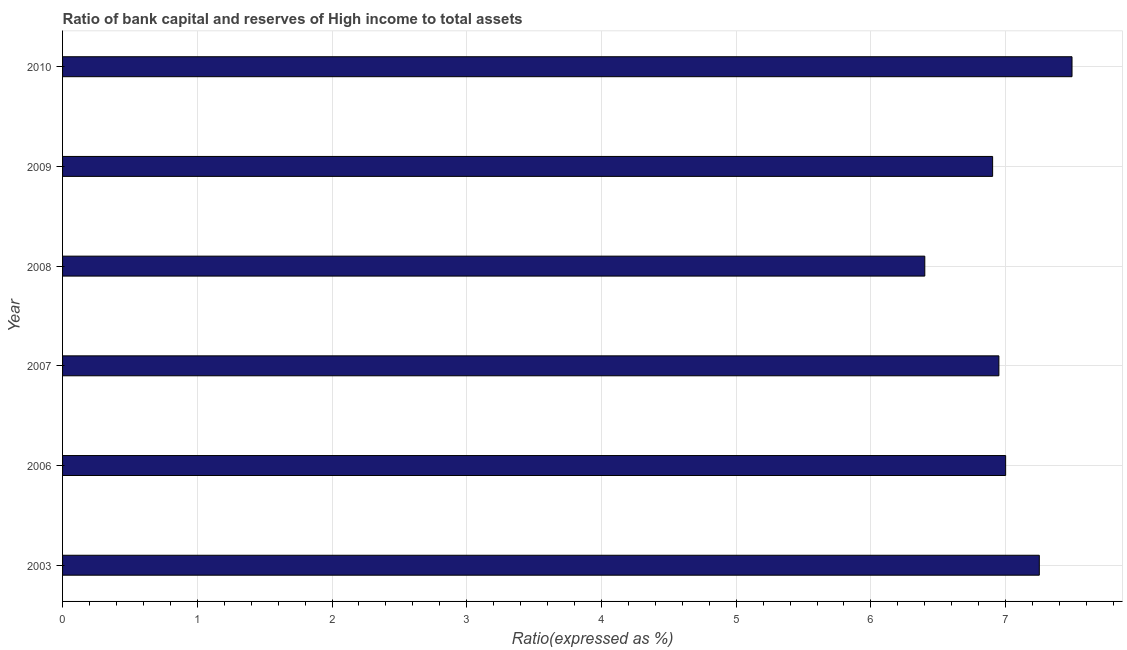Does the graph contain any zero values?
Keep it short and to the point. No. Does the graph contain grids?
Provide a short and direct response. Yes. What is the title of the graph?
Provide a succinct answer. Ratio of bank capital and reserves of High income to total assets. What is the label or title of the X-axis?
Give a very brief answer. Ratio(expressed as %). What is the bank capital to assets ratio in 2007?
Offer a very short reply. 6.95. Across all years, what is the maximum bank capital to assets ratio?
Make the answer very short. 7.49. In which year was the bank capital to assets ratio minimum?
Provide a succinct answer. 2008. What is the sum of the bank capital to assets ratio?
Ensure brevity in your answer.  42. What is the difference between the bank capital to assets ratio in 2006 and 2008?
Provide a succinct answer. 0.6. What is the average bank capital to assets ratio per year?
Your response must be concise. 7. What is the median bank capital to assets ratio?
Make the answer very short. 6.97. In how many years, is the bank capital to assets ratio greater than 5.4 %?
Give a very brief answer. 6. Do a majority of the years between 2008 and 2007 (inclusive) have bank capital to assets ratio greater than 5 %?
Your answer should be very brief. No. What is the ratio of the bank capital to assets ratio in 2003 to that in 2007?
Offer a terse response. 1.04. What is the difference between the highest and the second highest bank capital to assets ratio?
Offer a very short reply. 0.24. Is the sum of the bank capital to assets ratio in 2006 and 2010 greater than the maximum bank capital to assets ratio across all years?
Ensure brevity in your answer.  Yes. What is the difference between the highest and the lowest bank capital to assets ratio?
Ensure brevity in your answer.  1.09. In how many years, is the bank capital to assets ratio greater than the average bank capital to assets ratio taken over all years?
Provide a succinct answer. 3. How many years are there in the graph?
Your answer should be compact. 6. What is the difference between two consecutive major ticks on the X-axis?
Offer a terse response. 1. Are the values on the major ticks of X-axis written in scientific E-notation?
Offer a terse response. No. What is the Ratio(expressed as %) in 2003?
Offer a very short reply. 7.25. What is the Ratio(expressed as %) of 2007?
Your response must be concise. 6.95. What is the Ratio(expressed as %) of 2008?
Your answer should be very brief. 6.4. What is the Ratio(expressed as %) in 2009?
Keep it short and to the point. 6.9. What is the Ratio(expressed as %) in 2010?
Offer a terse response. 7.49. What is the difference between the Ratio(expressed as %) in 2003 and 2007?
Ensure brevity in your answer.  0.3. What is the difference between the Ratio(expressed as %) in 2003 and 2009?
Provide a short and direct response. 0.35. What is the difference between the Ratio(expressed as %) in 2003 and 2010?
Make the answer very short. -0.24. What is the difference between the Ratio(expressed as %) in 2006 and 2009?
Your answer should be very brief. 0.1. What is the difference between the Ratio(expressed as %) in 2006 and 2010?
Give a very brief answer. -0.49. What is the difference between the Ratio(expressed as %) in 2007 and 2008?
Make the answer very short. 0.55. What is the difference between the Ratio(expressed as %) in 2007 and 2009?
Provide a short and direct response. 0.05. What is the difference between the Ratio(expressed as %) in 2007 and 2010?
Provide a succinct answer. -0.54. What is the difference between the Ratio(expressed as %) in 2008 and 2009?
Keep it short and to the point. -0.5. What is the difference between the Ratio(expressed as %) in 2008 and 2010?
Ensure brevity in your answer.  -1.09. What is the difference between the Ratio(expressed as %) in 2009 and 2010?
Provide a succinct answer. -0.59. What is the ratio of the Ratio(expressed as %) in 2003 to that in 2006?
Provide a succinct answer. 1.04. What is the ratio of the Ratio(expressed as %) in 2003 to that in 2007?
Your response must be concise. 1.04. What is the ratio of the Ratio(expressed as %) in 2003 to that in 2008?
Give a very brief answer. 1.13. What is the ratio of the Ratio(expressed as %) in 2003 to that in 2009?
Offer a terse response. 1.05. What is the ratio of the Ratio(expressed as %) in 2003 to that in 2010?
Give a very brief answer. 0.97. What is the ratio of the Ratio(expressed as %) in 2006 to that in 2008?
Provide a succinct answer. 1.09. What is the ratio of the Ratio(expressed as %) in 2006 to that in 2010?
Make the answer very short. 0.93. What is the ratio of the Ratio(expressed as %) in 2007 to that in 2008?
Offer a very short reply. 1.09. What is the ratio of the Ratio(expressed as %) in 2007 to that in 2010?
Offer a terse response. 0.93. What is the ratio of the Ratio(expressed as %) in 2008 to that in 2009?
Give a very brief answer. 0.93. What is the ratio of the Ratio(expressed as %) in 2008 to that in 2010?
Ensure brevity in your answer.  0.85. What is the ratio of the Ratio(expressed as %) in 2009 to that in 2010?
Offer a terse response. 0.92. 